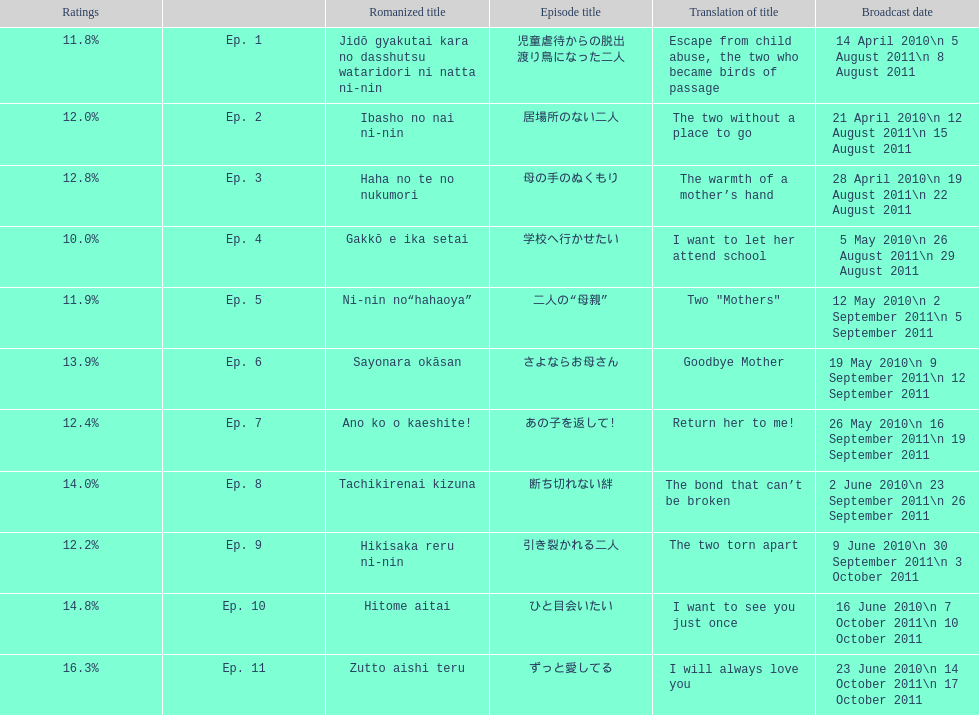How many episodes had a consecutive rating over 11%? 7. 